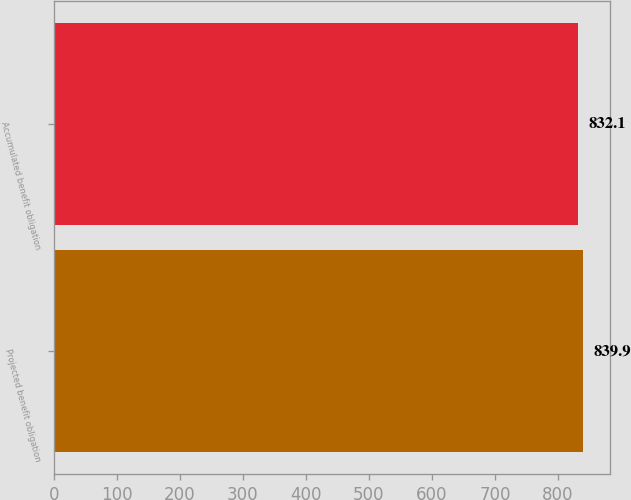Convert chart to OTSL. <chart><loc_0><loc_0><loc_500><loc_500><bar_chart><fcel>Projected benefit obligation<fcel>Accumulated benefit obligation<nl><fcel>839.9<fcel>832.1<nl></chart> 